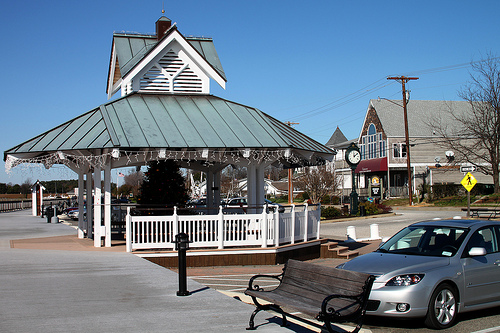Suppose you are drawing a parallel between this setting and a scene in a famous movie. Which movie scene does it remind you of, and why? This charming setting could remind one of the gazebo scene in 'The Sound of Music' where the characters express their emotions through song and dance. The picturesque gazebo and the peaceful surroundings evoke a sense of nostalgia and romance, much like the movie's iconic moments of serenading and heartfelt conversations against a beautiful backdrop. Do you think this location could be used in a mystery novel? Describe a potential plot. Absolutely! This serene and seemingly idyllic location could serve as the perfect setting for a mystery novel. The plot could revolve around a tight-knit community shaken by the disappearance of a beloved local. The gazebo, with its central location, becomes a key site for unraveling the clues. Late-night meetings and suspicious activities observed at the gazebo lead the protagonist on a winding trail of secrets and hidden histories within the town. With each chapter, the tranquil surroundings juxtapose the growing tension and suspense, culminating in a startling revelation connected to the gazebo's past. 